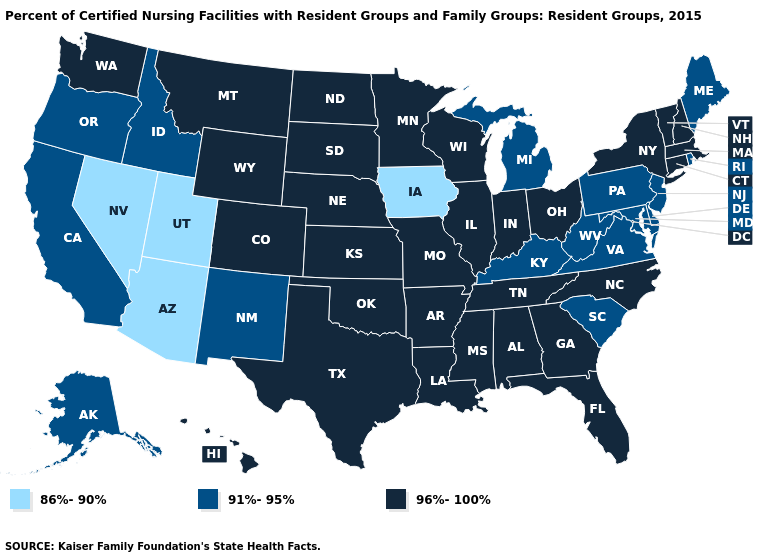Does Texas have a lower value than Louisiana?
Quick response, please. No. What is the value of Virginia?
Short answer required. 91%-95%. Which states have the highest value in the USA?
Give a very brief answer. Alabama, Arkansas, Colorado, Connecticut, Florida, Georgia, Hawaii, Illinois, Indiana, Kansas, Louisiana, Massachusetts, Minnesota, Mississippi, Missouri, Montana, Nebraska, New Hampshire, New York, North Carolina, North Dakota, Ohio, Oklahoma, South Dakota, Tennessee, Texas, Vermont, Washington, Wisconsin, Wyoming. What is the value of Washington?
Answer briefly. 96%-100%. What is the value of Nevada?
Answer briefly. 86%-90%. What is the value of Iowa?
Quick response, please. 86%-90%. Does Iowa have the lowest value in the USA?
Short answer required. Yes. Name the states that have a value in the range 91%-95%?
Write a very short answer. Alaska, California, Delaware, Idaho, Kentucky, Maine, Maryland, Michigan, New Jersey, New Mexico, Oregon, Pennsylvania, Rhode Island, South Carolina, Virginia, West Virginia. What is the highest value in the USA?
Give a very brief answer. 96%-100%. What is the value of Alabama?
Short answer required. 96%-100%. Does Nevada have the highest value in the USA?
Answer briefly. No. Does Illinois have the lowest value in the USA?
Answer briefly. No. What is the value of Vermont?
Write a very short answer. 96%-100%. Does Montana have the highest value in the West?
Give a very brief answer. Yes. 